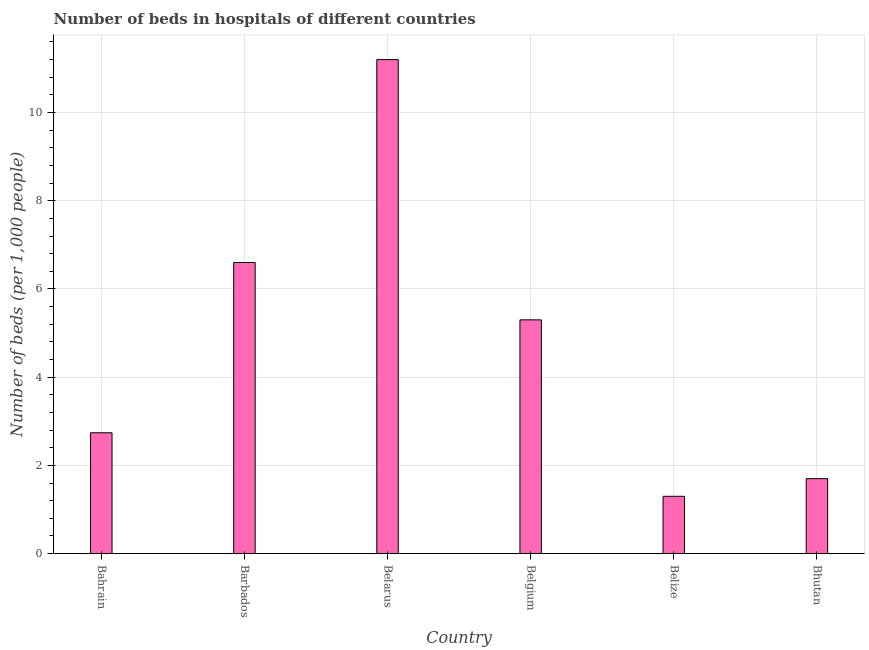Does the graph contain grids?
Offer a terse response. Yes. What is the title of the graph?
Provide a short and direct response. Number of beds in hospitals of different countries. What is the label or title of the X-axis?
Offer a very short reply. Country. What is the label or title of the Y-axis?
Your response must be concise. Number of beds (per 1,0 people). Across all countries, what is the maximum number of hospital beds?
Your answer should be very brief. 11.2. In which country was the number of hospital beds maximum?
Your answer should be very brief. Belarus. In which country was the number of hospital beds minimum?
Provide a succinct answer. Belize. What is the sum of the number of hospital beds?
Keep it short and to the point. 28.84. What is the difference between the number of hospital beds in Bahrain and Belize?
Provide a short and direct response. 1.44. What is the average number of hospital beds per country?
Your answer should be compact. 4.81. What is the median number of hospital beds?
Offer a terse response. 4.02. In how many countries, is the number of hospital beds greater than 1.2 %?
Keep it short and to the point. 6. What is the ratio of the number of hospital beds in Barbados to that in Belize?
Keep it short and to the point. 5.08. Is the difference between the number of hospital beds in Bahrain and Barbados greater than the difference between any two countries?
Your answer should be very brief. No. How many bars are there?
Offer a terse response. 6. Are all the bars in the graph horizontal?
Ensure brevity in your answer.  No. How many countries are there in the graph?
Your answer should be very brief. 6. Are the values on the major ticks of Y-axis written in scientific E-notation?
Give a very brief answer. No. What is the Number of beds (per 1,000 people) in Bahrain?
Give a very brief answer. 2.74. What is the Number of beds (per 1,000 people) in Belarus?
Your answer should be very brief. 11.2. What is the Number of beds (per 1,000 people) in Belize?
Your answer should be compact. 1.3. What is the Number of beds (per 1,000 people) in Bhutan?
Ensure brevity in your answer.  1.7. What is the difference between the Number of beds (per 1,000 people) in Bahrain and Barbados?
Keep it short and to the point. -3.86. What is the difference between the Number of beds (per 1,000 people) in Bahrain and Belarus?
Your response must be concise. -8.46. What is the difference between the Number of beds (per 1,000 people) in Bahrain and Belgium?
Your answer should be very brief. -2.56. What is the difference between the Number of beds (per 1,000 people) in Bahrain and Belize?
Offer a very short reply. 1.44. What is the difference between the Number of beds (per 1,000 people) in Barbados and Belarus?
Provide a short and direct response. -4.6. What is the difference between the Number of beds (per 1,000 people) in Barbados and Belgium?
Your answer should be compact. 1.3. What is the difference between the Number of beds (per 1,000 people) in Barbados and Belize?
Your response must be concise. 5.3. What is the difference between the Number of beds (per 1,000 people) in Barbados and Bhutan?
Give a very brief answer. 4.9. What is the difference between the Number of beds (per 1,000 people) in Belarus and Belgium?
Provide a succinct answer. 5.9. What is the difference between the Number of beds (per 1,000 people) in Belarus and Belize?
Make the answer very short. 9.9. What is the difference between the Number of beds (per 1,000 people) in Belarus and Bhutan?
Offer a very short reply. 9.5. What is the difference between the Number of beds (per 1,000 people) in Belgium and Belize?
Your response must be concise. 4. What is the difference between the Number of beds (per 1,000 people) in Belgium and Bhutan?
Give a very brief answer. 3.6. What is the ratio of the Number of beds (per 1,000 people) in Bahrain to that in Barbados?
Your response must be concise. 0.41. What is the ratio of the Number of beds (per 1,000 people) in Bahrain to that in Belarus?
Give a very brief answer. 0.24. What is the ratio of the Number of beds (per 1,000 people) in Bahrain to that in Belgium?
Offer a terse response. 0.52. What is the ratio of the Number of beds (per 1,000 people) in Bahrain to that in Belize?
Provide a succinct answer. 2.11. What is the ratio of the Number of beds (per 1,000 people) in Bahrain to that in Bhutan?
Your answer should be compact. 1.61. What is the ratio of the Number of beds (per 1,000 people) in Barbados to that in Belarus?
Your response must be concise. 0.59. What is the ratio of the Number of beds (per 1,000 people) in Barbados to that in Belgium?
Provide a succinct answer. 1.25. What is the ratio of the Number of beds (per 1,000 people) in Barbados to that in Belize?
Your answer should be very brief. 5.08. What is the ratio of the Number of beds (per 1,000 people) in Barbados to that in Bhutan?
Your answer should be compact. 3.88. What is the ratio of the Number of beds (per 1,000 people) in Belarus to that in Belgium?
Your answer should be compact. 2.11. What is the ratio of the Number of beds (per 1,000 people) in Belarus to that in Belize?
Your response must be concise. 8.62. What is the ratio of the Number of beds (per 1,000 people) in Belarus to that in Bhutan?
Provide a short and direct response. 6.59. What is the ratio of the Number of beds (per 1,000 people) in Belgium to that in Belize?
Give a very brief answer. 4.08. What is the ratio of the Number of beds (per 1,000 people) in Belgium to that in Bhutan?
Give a very brief answer. 3.12. What is the ratio of the Number of beds (per 1,000 people) in Belize to that in Bhutan?
Keep it short and to the point. 0.77. 